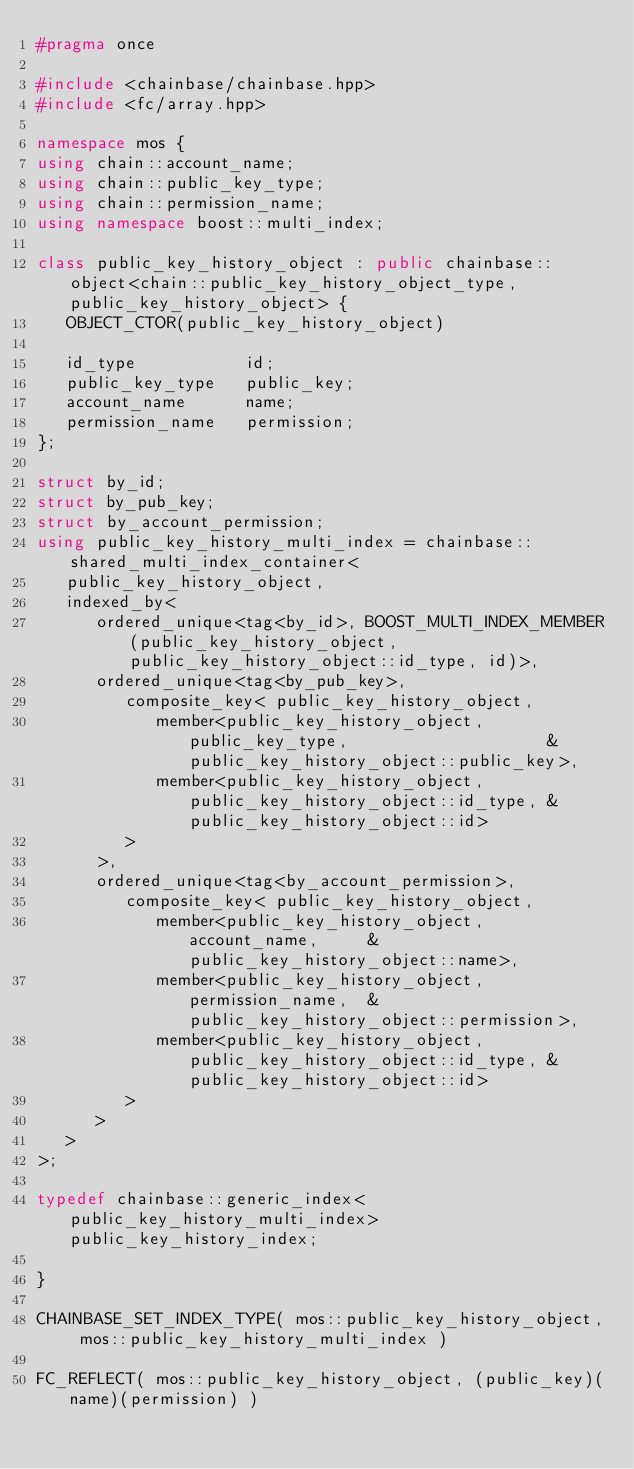Convert code to text. <code><loc_0><loc_0><loc_500><loc_500><_C++_>#pragma once

#include <chainbase/chainbase.hpp>
#include <fc/array.hpp>

namespace mos {
using chain::account_name;
using chain::public_key_type;
using chain::permission_name;
using namespace boost::multi_index;

class public_key_history_object : public chainbase::object<chain::public_key_history_object_type, public_key_history_object> {
   OBJECT_CTOR(public_key_history_object)

   id_type           id;
   public_key_type   public_key;
   account_name      name;
   permission_name   permission;
};

struct by_id;
struct by_pub_key;
struct by_account_permission;
using public_key_history_multi_index = chainbase::shared_multi_index_container<
   public_key_history_object,
   indexed_by<
      ordered_unique<tag<by_id>, BOOST_MULTI_INDEX_MEMBER(public_key_history_object, public_key_history_object::id_type, id)>,
      ordered_unique<tag<by_pub_key>,
         composite_key< public_key_history_object,
            member<public_key_history_object, public_key_type,                    &public_key_history_object::public_key>,
            member<public_key_history_object, public_key_history_object::id_type, &public_key_history_object::id>
         >
      >,
      ordered_unique<tag<by_account_permission>,
         composite_key< public_key_history_object,
            member<public_key_history_object, account_name,     &public_key_history_object::name>,
            member<public_key_history_object, permission_name,  &public_key_history_object::permission>,
            member<public_key_history_object, public_key_history_object::id_type, &public_key_history_object::id>
         >
      >
   >
>;

typedef chainbase::generic_index<public_key_history_multi_index> public_key_history_index;

}

CHAINBASE_SET_INDEX_TYPE( mos::public_key_history_object, mos::public_key_history_multi_index )

FC_REFLECT( mos::public_key_history_object, (public_key)(name)(permission) )

</code> 